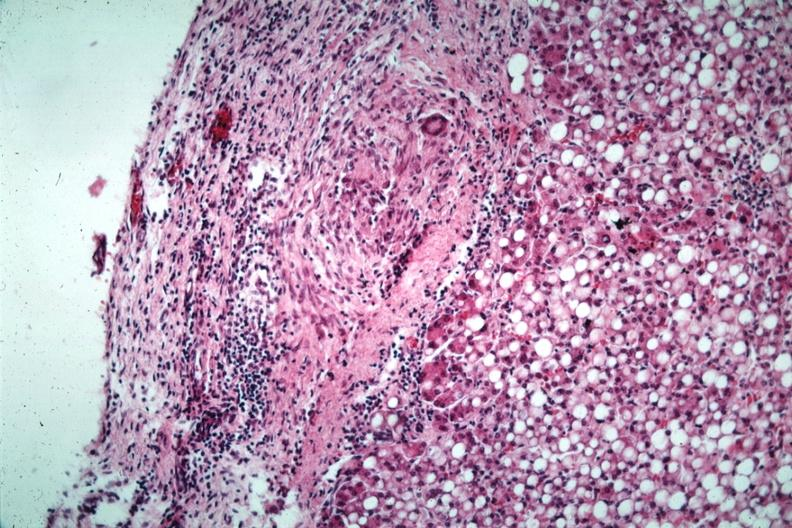what has marked fatty change?
Answer the question using a single word or phrase. Quite good liver 